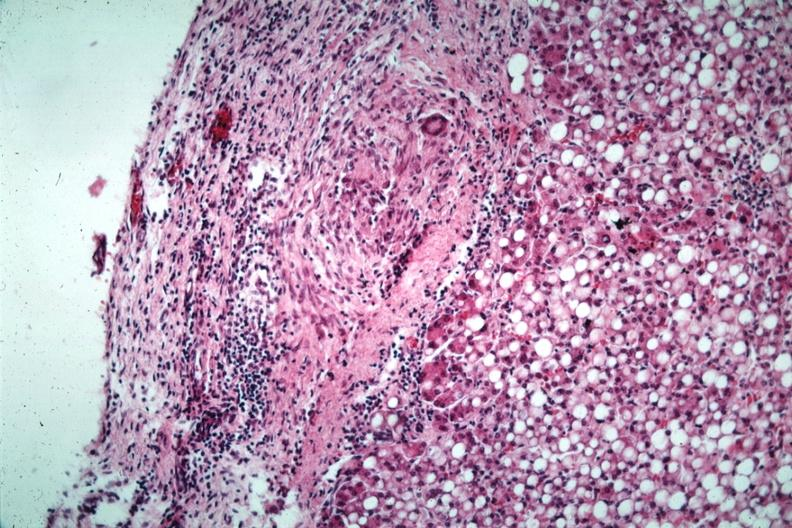what has marked fatty change?
Answer the question using a single word or phrase. Quite good liver 